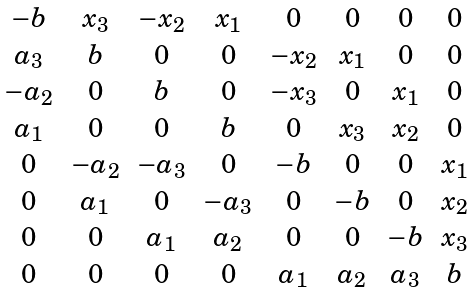Convert formula to latex. <formula><loc_0><loc_0><loc_500><loc_500>\begin{matrix} - b & x _ { 3 } & - x _ { 2 } & x _ { 1 } & 0 & 0 & 0 & 0 \\ a _ { 3 } & b & 0 & 0 & - x _ { 2 } & x _ { 1 } & 0 & 0 \\ - a _ { 2 } & 0 & b & 0 & - x _ { 3 } & 0 & x _ { 1 } & 0 \\ a _ { 1 } & 0 & 0 & b & 0 & x _ { 3 } & x _ { 2 } & 0 \\ 0 & - a _ { 2 } & - a _ { 3 } & 0 & - b & 0 & 0 & x _ { 1 } \\ 0 & a _ { 1 } & 0 & - a _ { 3 } & 0 & - b & 0 & x _ { 2 } \\ 0 & 0 & a _ { 1 } & a _ { 2 } & 0 & 0 & - b & x _ { 3 } \\ 0 & 0 & 0 & 0 & a _ { 1 } & a _ { 2 } & a _ { 3 } & b \end{matrix}</formula> 